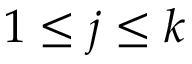<formula> <loc_0><loc_0><loc_500><loc_500>1 \leq j \leq k</formula> 